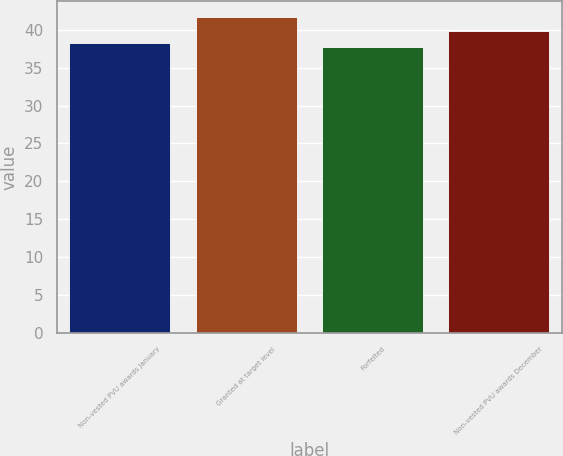Convert chart to OTSL. <chart><loc_0><loc_0><loc_500><loc_500><bar_chart><fcel>Non-vested PVU awards January<fcel>Granted at target level<fcel>Forfeited<fcel>Non-vested PVU awards December<nl><fcel>38.29<fcel>41.7<fcel>37.73<fcel>39.85<nl></chart> 